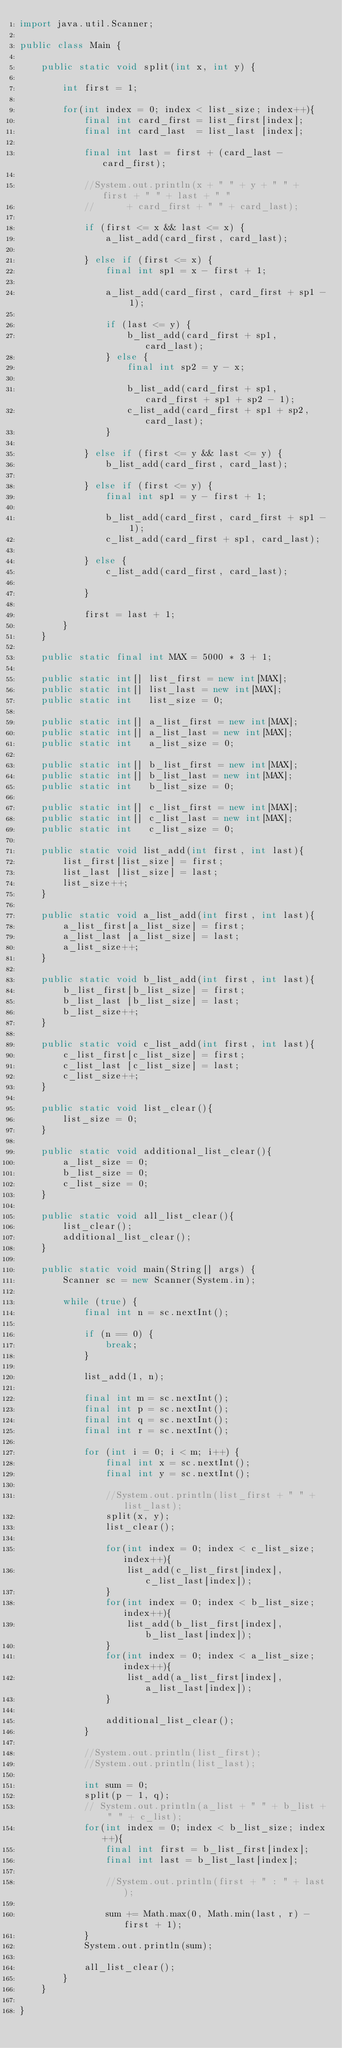<code> <loc_0><loc_0><loc_500><loc_500><_Java_>import java.util.Scanner;

public class Main {

	public static void split(int x, int y) {

		int first = 1;
		
		for(int index = 0; index < list_size; index++){
			final int card_first = list_first[index];
			final int card_last  = list_last [index];

			final int last = first + (card_last - card_first);

			//System.out.println(x + " " + y + " " + first + " " + last + " "
			//		+ card_first + " " + card_last);

			if (first <= x && last <= x) {
				a_list_add(card_first, card_last);
				
			} else if (first <= x) {
				final int sp1 = x - first + 1;
				
				a_list_add(card_first, card_first + sp1 - 1);

				if (last <= y) {
					b_list_add(card_first + sp1, card_last);
				} else {
					final int sp2 = y - x;
					
					b_list_add(card_first + sp1, card_first + sp1 + sp2 - 1);
					c_list_add(card_first + sp1 + sp2, card_last);
				}

			} else if (first <= y && last <= y) {
				b_list_add(card_first, card_last);

			} else if (first <= y) {
				final int sp1 = y - first + 1;

				b_list_add(card_first, card_first + sp1 - 1);
				c_list_add(card_first + sp1, card_last);
				
			} else {
				c_list_add(card_first, card_last);
				
			}

			first = last + 1;
		}
	}
	
	public static final int MAX = 5000 * 3 + 1;
	
	public static int[] list_first = new int[MAX];
	public static int[] list_last = new int[MAX];
	public static int   list_size = 0;
	
	public static int[] a_list_first = new int[MAX];
	public static int[] a_list_last = new int[MAX];
	public static int   a_list_size = 0;
	
	public static int[] b_list_first = new int[MAX];
	public static int[] b_list_last = new int[MAX];
	public static int   b_list_size = 0;
	
	public static int[] c_list_first = new int[MAX];
	public static int[] c_list_last = new int[MAX];
	public static int   c_list_size = 0;
	
	public static void list_add(int first, int last){
		list_first[list_size] = first;
		list_last [list_size] = last;
		list_size++;
	}
	
	public static void a_list_add(int first, int last){
		a_list_first[a_list_size] = first;
		a_list_last [a_list_size] = last;
		a_list_size++;
	}
	
	public static void b_list_add(int first, int last){
		b_list_first[b_list_size] = first;
		b_list_last [b_list_size] = last;
		b_list_size++;
	}
	
	public static void c_list_add(int first, int last){
		c_list_first[c_list_size] = first;
		c_list_last [c_list_size] = last;
		c_list_size++;
	}
	
	public static void list_clear(){
		list_size = 0;
	}
	
	public static void additional_list_clear(){
		a_list_size = 0;
		b_list_size = 0;
		c_list_size = 0;
	}
	
	public static void all_list_clear(){
		list_clear();
		additional_list_clear();
	}
	
	public static void main(String[] args) {
		Scanner sc = new Scanner(System.in);

		while (true) {
			final int n = sc.nextInt();

			if (n == 0) {
				break;
			}

			list_add(1, n);

			final int m = sc.nextInt();
			final int p = sc.nextInt();
			final int q = sc.nextInt();
			final int r = sc.nextInt();

			for (int i = 0; i < m; i++) {
				final int x = sc.nextInt();
				final int y = sc.nextInt();

				//System.out.println(list_first + " " + list_last);
				split(x, y);
				list_clear();
				
				for(int index = 0; index < c_list_size; index++){
					list_add(c_list_first[index], c_list_last[index]);
				}
				for(int index = 0; index < b_list_size; index++){
					list_add(b_list_first[index], b_list_last[index]);
				}
				for(int index = 0; index < a_list_size; index++){
					list_add(a_list_first[index], a_list_last[index]);
				}

				additional_list_clear();
			}

			//System.out.println(list_first);
			//System.out.println(list_last);

			int sum = 0;
			split(p - 1, q);
			// System.out.println(a_list + " " + b_list + " " + c_list);
			for(int index = 0; index < b_list_size; index++){
				final int first = b_list_first[index];
				final int last = b_list_last[index];

				//System.out.println(first + " : " + last);

				sum += Math.max(0, Math.min(last, r) - first + 1);
			}
			System.out.println(sum);
			
			all_list_clear();
		}
	}

}</code> 